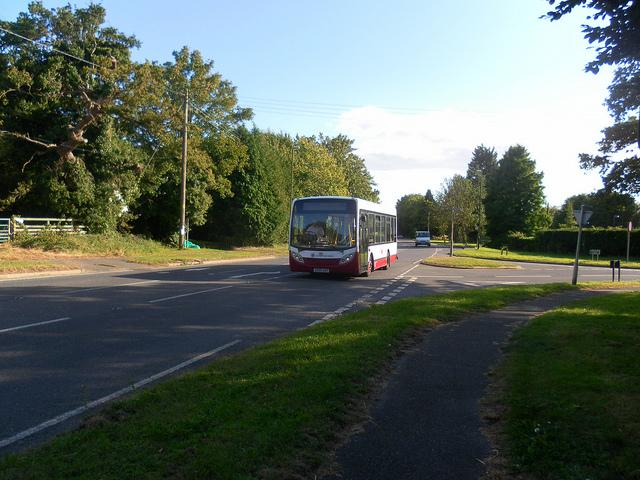Why is the windshield on the bus so large?

Choices:
A) reinforcement
B) aerodynamics
C) visibility
D) safety visibility 